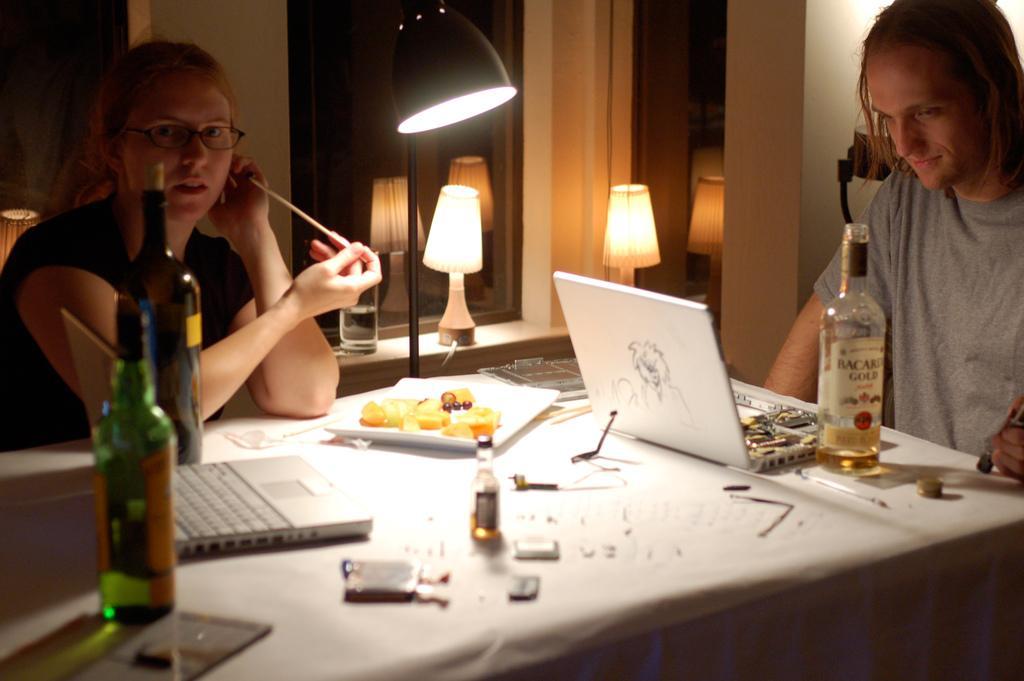Please provide a concise description of this image. This is a picture taken in a room, there are two persons sitting on chairs. The woman in black t shirt was holding a chopstick in front of these people there is a table on the table there are laptops, bottle, plate and some food items. Behind the people there is a lamp and a mirror. In front of the mirror there are two lamps on the wall and glass. 